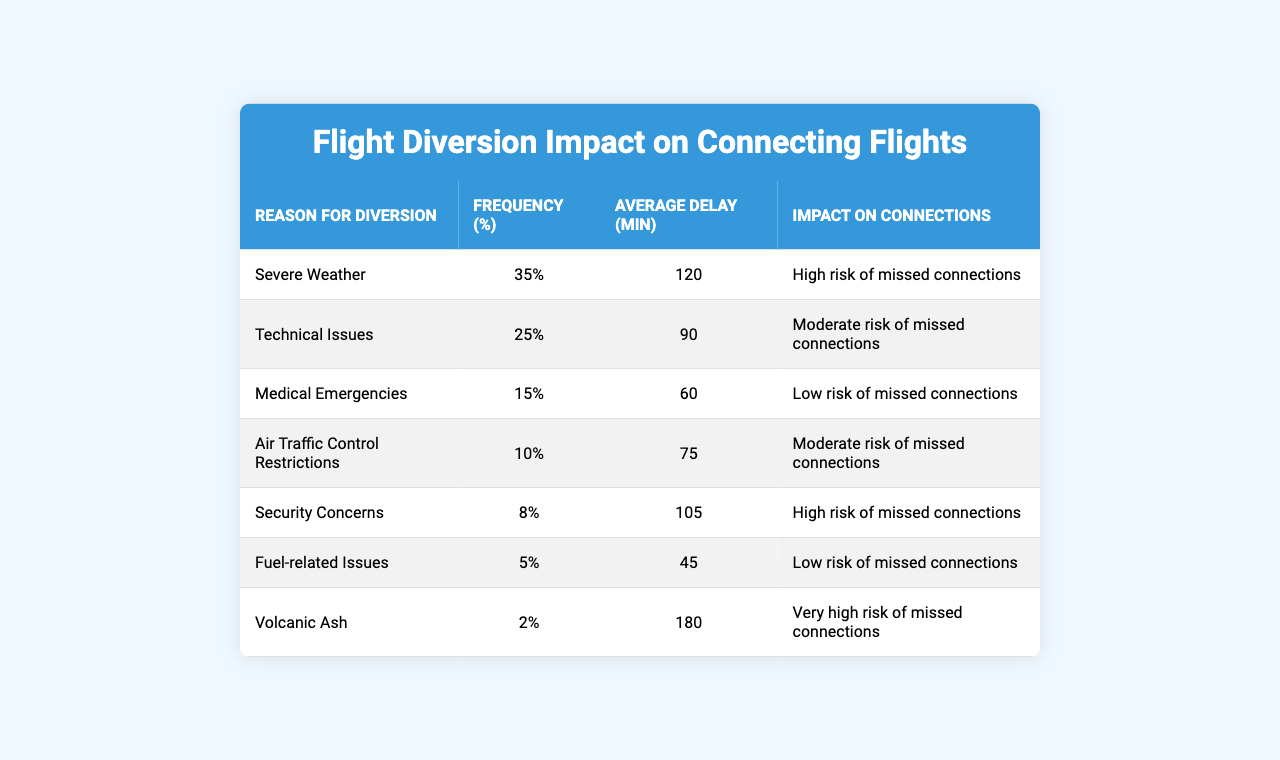What is the most common reason for flight diversions? The table lists the reasons for flight diversions along with their frequency percentages. The highest frequency is for "Severe Weather," which is 35%.
Answer: Severe Weather What is the average delay caused by technical issues? According to the table, the average delay for technical issues is explicitly stated as 90 minutes.
Answer: 90 minutes Which diversion reason has the least impact on connections? The impact on connections is categorized as "Low risk of missed connections." The reasons with this impact are "Medical Emergencies" and "Fuel-related Issues."
Answer: Medical Emergencies and Fuel-related Issues What percentage of diversions are due to air traffic control restrictions? In the table, air traffic control restrictions account for 10% of the total diversions, as indicated in the frequency column.
Answer: 10% What is the total average delay from severe weather and security concerns? First, add the average delays: Severe Weather (120 min) + Security Concerns (105 min) = 225 minutes. Then sum it up.
Answer: 225 minutes Is the risk of missed connections higher for severe weather than for technical issues? The impact for severe weather is "High risk of missed connections," while for technical issues it is "Moderate risk of missed connections." Since "High" is greater than "Moderate," the statement is true.
Answer: Yes Which diversion reason leads to the highest average delay? By checking the average delays for each reason, "Volcanic Ash" has the highest average delay at 180 minutes.
Answer: Volcanic Ash How many diversion categories lead to a high risk of missed connections? The table shows that "Severe Weather" and "Security Concerns" both indicate a "High risk of missed connections," so there are two categories.
Answer: 2 categories What is the average delay for diversion reasons that have a low risk of missed connections? The average delays for "Medical Emergencies" (60 min) and "Fuel-related Issues" (45 min) must be calculated. (60 + 45) / 2 = 52.5 minutes.
Answer: 52.5 minutes If a flight experiences a 120-minute delay from severe weather, what is the likelihood of missing a connection? Since the table categorizes severe weather as "High risk of missed connections," there's a significant likelihood of missing connections regardless of the specific delay time.
Answer: High risk of missed connections 